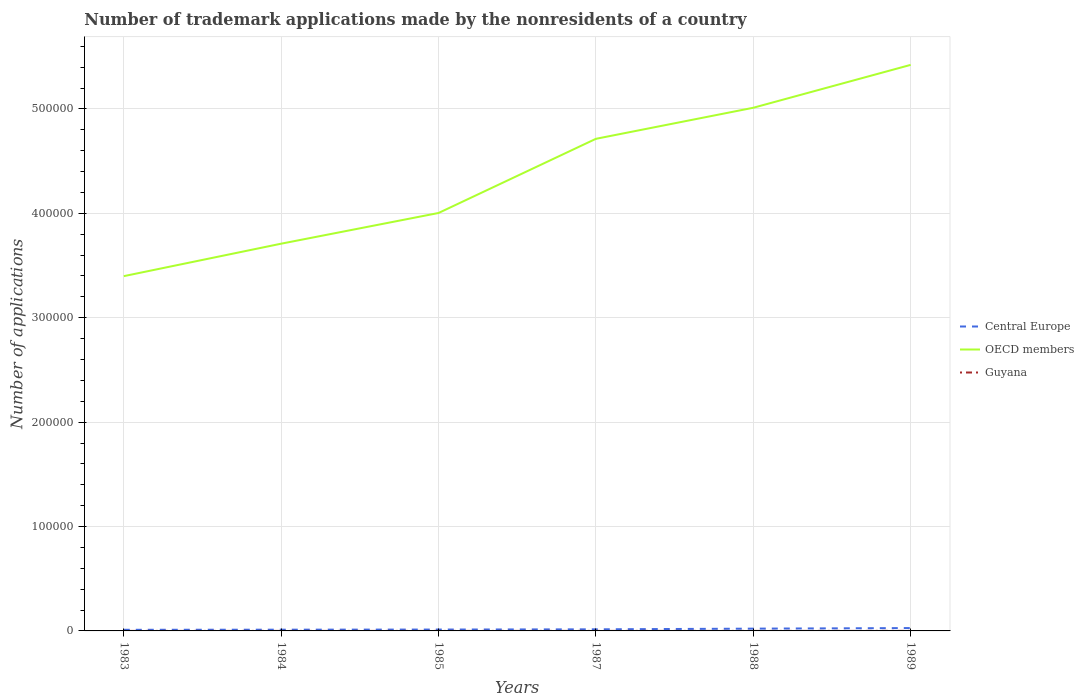Does the line corresponding to Guyana intersect with the line corresponding to Central Europe?
Your answer should be very brief. No. Across all years, what is the maximum number of trademark applications made by the nonresidents in Guyana?
Offer a terse response. 10. What is the total number of trademark applications made by the nonresidents in Central Europe in the graph?
Your response must be concise. -551. What is the difference between the highest and the second highest number of trademark applications made by the nonresidents in OECD members?
Your response must be concise. 2.02e+05. What is the difference between the highest and the lowest number of trademark applications made by the nonresidents in OECD members?
Your response must be concise. 3. Is the number of trademark applications made by the nonresidents in OECD members strictly greater than the number of trademark applications made by the nonresidents in Guyana over the years?
Your answer should be compact. No. How many lines are there?
Provide a succinct answer. 3. How many years are there in the graph?
Keep it short and to the point. 6. Are the values on the major ticks of Y-axis written in scientific E-notation?
Ensure brevity in your answer.  No. Does the graph contain any zero values?
Offer a very short reply. No. How many legend labels are there?
Your response must be concise. 3. What is the title of the graph?
Make the answer very short. Number of trademark applications made by the nonresidents of a country. What is the label or title of the X-axis?
Your response must be concise. Years. What is the label or title of the Y-axis?
Provide a short and direct response. Number of applications. What is the Number of applications in Central Europe in 1983?
Provide a short and direct response. 1070. What is the Number of applications of OECD members in 1983?
Make the answer very short. 3.40e+05. What is the Number of applications of Central Europe in 1984?
Offer a very short reply. 1181. What is the Number of applications in OECD members in 1984?
Ensure brevity in your answer.  3.71e+05. What is the Number of applications in Guyana in 1984?
Make the answer very short. 15. What is the Number of applications in Central Europe in 1985?
Give a very brief answer. 1312. What is the Number of applications in OECD members in 1985?
Make the answer very short. 4.00e+05. What is the Number of applications in Guyana in 1985?
Provide a short and direct response. 10. What is the Number of applications of Central Europe in 1987?
Your answer should be compact. 1528. What is the Number of applications of OECD members in 1987?
Give a very brief answer. 4.71e+05. What is the Number of applications in Guyana in 1987?
Your response must be concise. 29. What is the Number of applications in Central Europe in 1988?
Offer a very short reply. 2179. What is the Number of applications of OECD members in 1988?
Offer a terse response. 5.01e+05. What is the Number of applications of Central Europe in 1989?
Make the answer very short. 2730. What is the Number of applications of OECD members in 1989?
Provide a succinct answer. 5.42e+05. Across all years, what is the maximum Number of applications of Central Europe?
Offer a terse response. 2730. Across all years, what is the maximum Number of applications of OECD members?
Offer a terse response. 5.42e+05. Across all years, what is the maximum Number of applications in Guyana?
Keep it short and to the point. 47. Across all years, what is the minimum Number of applications of Central Europe?
Your response must be concise. 1070. Across all years, what is the minimum Number of applications of OECD members?
Your answer should be very brief. 3.40e+05. What is the total Number of applications of Central Europe in the graph?
Provide a succinct answer. 10000. What is the total Number of applications of OECD members in the graph?
Offer a terse response. 2.63e+06. What is the total Number of applications in Guyana in the graph?
Provide a succinct answer. 125. What is the difference between the Number of applications of Central Europe in 1983 and that in 1984?
Your answer should be compact. -111. What is the difference between the Number of applications in OECD members in 1983 and that in 1984?
Make the answer very short. -3.11e+04. What is the difference between the Number of applications in Central Europe in 1983 and that in 1985?
Keep it short and to the point. -242. What is the difference between the Number of applications of OECD members in 1983 and that in 1985?
Provide a succinct answer. -6.05e+04. What is the difference between the Number of applications of Central Europe in 1983 and that in 1987?
Your answer should be compact. -458. What is the difference between the Number of applications of OECD members in 1983 and that in 1987?
Your response must be concise. -1.32e+05. What is the difference between the Number of applications in Guyana in 1983 and that in 1987?
Give a very brief answer. -16. What is the difference between the Number of applications of Central Europe in 1983 and that in 1988?
Make the answer very short. -1109. What is the difference between the Number of applications of OECD members in 1983 and that in 1988?
Give a very brief answer. -1.61e+05. What is the difference between the Number of applications of Guyana in 1983 and that in 1988?
Give a very brief answer. 2. What is the difference between the Number of applications in Central Europe in 1983 and that in 1989?
Your answer should be very brief. -1660. What is the difference between the Number of applications of OECD members in 1983 and that in 1989?
Provide a succinct answer. -2.02e+05. What is the difference between the Number of applications of Guyana in 1983 and that in 1989?
Offer a very short reply. -34. What is the difference between the Number of applications of Central Europe in 1984 and that in 1985?
Offer a terse response. -131. What is the difference between the Number of applications in OECD members in 1984 and that in 1985?
Ensure brevity in your answer.  -2.94e+04. What is the difference between the Number of applications of Central Europe in 1984 and that in 1987?
Make the answer very short. -347. What is the difference between the Number of applications in OECD members in 1984 and that in 1987?
Ensure brevity in your answer.  -1.00e+05. What is the difference between the Number of applications in Central Europe in 1984 and that in 1988?
Give a very brief answer. -998. What is the difference between the Number of applications of OECD members in 1984 and that in 1988?
Provide a succinct answer. -1.30e+05. What is the difference between the Number of applications in Guyana in 1984 and that in 1988?
Make the answer very short. 4. What is the difference between the Number of applications of Central Europe in 1984 and that in 1989?
Your answer should be very brief. -1549. What is the difference between the Number of applications in OECD members in 1984 and that in 1989?
Provide a short and direct response. -1.71e+05. What is the difference between the Number of applications in Guyana in 1984 and that in 1989?
Provide a succinct answer. -32. What is the difference between the Number of applications in Central Europe in 1985 and that in 1987?
Offer a very short reply. -216. What is the difference between the Number of applications in OECD members in 1985 and that in 1987?
Your answer should be very brief. -7.10e+04. What is the difference between the Number of applications of Central Europe in 1985 and that in 1988?
Make the answer very short. -867. What is the difference between the Number of applications in OECD members in 1985 and that in 1988?
Give a very brief answer. -1.01e+05. What is the difference between the Number of applications in Central Europe in 1985 and that in 1989?
Your answer should be very brief. -1418. What is the difference between the Number of applications of OECD members in 1985 and that in 1989?
Your response must be concise. -1.42e+05. What is the difference between the Number of applications of Guyana in 1985 and that in 1989?
Provide a succinct answer. -37. What is the difference between the Number of applications in Central Europe in 1987 and that in 1988?
Ensure brevity in your answer.  -651. What is the difference between the Number of applications of OECD members in 1987 and that in 1988?
Your answer should be very brief. -2.98e+04. What is the difference between the Number of applications of Central Europe in 1987 and that in 1989?
Your answer should be compact. -1202. What is the difference between the Number of applications of OECD members in 1987 and that in 1989?
Provide a short and direct response. -7.08e+04. What is the difference between the Number of applications of Central Europe in 1988 and that in 1989?
Ensure brevity in your answer.  -551. What is the difference between the Number of applications of OECD members in 1988 and that in 1989?
Provide a succinct answer. -4.11e+04. What is the difference between the Number of applications of Guyana in 1988 and that in 1989?
Your answer should be very brief. -36. What is the difference between the Number of applications in Central Europe in 1983 and the Number of applications in OECD members in 1984?
Your answer should be compact. -3.70e+05. What is the difference between the Number of applications of Central Europe in 1983 and the Number of applications of Guyana in 1984?
Your answer should be compact. 1055. What is the difference between the Number of applications in OECD members in 1983 and the Number of applications in Guyana in 1984?
Ensure brevity in your answer.  3.40e+05. What is the difference between the Number of applications of Central Europe in 1983 and the Number of applications of OECD members in 1985?
Make the answer very short. -3.99e+05. What is the difference between the Number of applications of Central Europe in 1983 and the Number of applications of Guyana in 1985?
Provide a succinct answer. 1060. What is the difference between the Number of applications in OECD members in 1983 and the Number of applications in Guyana in 1985?
Your answer should be compact. 3.40e+05. What is the difference between the Number of applications of Central Europe in 1983 and the Number of applications of OECD members in 1987?
Your answer should be compact. -4.70e+05. What is the difference between the Number of applications in Central Europe in 1983 and the Number of applications in Guyana in 1987?
Make the answer very short. 1041. What is the difference between the Number of applications of OECD members in 1983 and the Number of applications of Guyana in 1987?
Your answer should be very brief. 3.40e+05. What is the difference between the Number of applications of Central Europe in 1983 and the Number of applications of OECD members in 1988?
Your answer should be compact. -5.00e+05. What is the difference between the Number of applications in Central Europe in 1983 and the Number of applications in Guyana in 1988?
Provide a short and direct response. 1059. What is the difference between the Number of applications in OECD members in 1983 and the Number of applications in Guyana in 1988?
Provide a short and direct response. 3.40e+05. What is the difference between the Number of applications of Central Europe in 1983 and the Number of applications of OECD members in 1989?
Your answer should be compact. -5.41e+05. What is the difference between the Number of applications of Central Europe in 1983 and the Number of applications of Guyana in 1989?
Provide a short and direct response. 1023. What is the difference between the Number of applications in OECD members in 1983 and the Number of applications in Guyana in 1989?
Make the answer very short. 3.40e+05. What is the difference between the Number of applications in Central Europe in 1984 and the Number of applications in OECD members in 1985?
Provide a short and direct response. -3.99e+05. What is the difference between the Number of applications in Central Europe in 1984 and the Number of applications in Guyana in 1985?
Your response must be concise. 1171. What is the difference between the Number of applications of OECD members in 1984 and the Number of applications of Guyana in 1985?
Provide a succinct answer. 3.71e+05. What is the difference between the Number of applications in Central Europe in 1984 and the Number of applications in OECD members in 1987?
Give a very brief answer. -4.70e+05. What is the difference between the Number of applications in Central Europe in 1984 and the Number of applications in Guyana in 1987?
Offer a terse response. 1152. What is the difference between the Number of applications in OECD members in 1984 and the Number of applications in Guyana in 1987?
Give a very brief answer. 3.71e+05. What is the difference between the Number of applications of Central Europe in 1984 and the Number of applications of OECD members in 1988?
Your response must be concise. -5.00e+05. What is the difference between the Number of applications of Central Europe in 1984 and the Number of applications of Guyana in 1988?
Ensure brevity in your answer.  1170. What is the difference between the Number of applications in OECD members in 1984 and the Number of applications in Guyana in 1988?
Your answer should be very brief. 3.71e+05. What is the difference between the Number of applications in Central Europe in 1984 and the Number of applications in OECD members in 1989?
Offer a very short reply. -5.41e+05. What is the difference between the Number of applications in Central Europe in 1984 and the Number of applications in Guyana in 1989?
Offer a terse response. 1134. What is the difference between the Number of applications in OECD members in 1984 and the Number of applications in Guyana in 1989?
Provide a short and direct response. 3.71e+05. What is the difference between the Number of applications of Central Europe in 1985 and the Number of applications of OECD members in 1987?
Ensure brevity in your answer.  -4.70e+05. What is the difference between the Number of applications in Central Europe in 1985 and the Number of applications in Guyana in 1987?
Make the answer very short. 1283. What is the difference between the Number of applications in OECD members in 1985 and the Number of applications in Guyana in 1987?
Offer a very short reply. 4.00e+05. What is the difference between the Number of applications in Central Europe in 1985 and the Number of applications in OECD members in 1988?
Ensure brevity in your answer.  -5.00e+05. What is the difference between the Number of applications of Central Europe in 1985 and the Number of applications of Guyana in 1988?
Provide a succinct answer. 1301. What is the difference between the Number of applications of OECD members in 1985 and the Number of applications of Guyana in 1988?
Offer a terse response. 4.00e+05. What is the difference between the Number of applications of Central Europe in 1985 and the Number of applications of OECD members in 1989?
Your answer should be very brief. -5.41e+05. What is the difference between the Number of applications of Central Europe in 1985 and the Number of applications of Guyana in 1989?
Offer a very short reply. 1265. What is the difference between the Number of applications of OECD members in 1985 and the Number of applications of Guyana in 1989?
Make the answer very short. 4.00e+05. What is the difference between the Number of applications in Central Europe in 1987 and the Number of applications in OECD members in 1988?
Your answer should be very brief. -5.00e+05. What is the difference between the Number of applications of Central Europe in 1987 and the Number of applications of Guyana in 1988?
Your answer should be compact. 1517. What is the difference between the Number of applications of OECD members in 1987 and the Number of applications of Guyana in 1988?
Ensure brevity in your answer.  4.71e+05. What is the difference between the Number of applications of Central Europe in 1987 and the Number of applications of OECD members in 1989?
Offer a terse response. -5.41e+05. What is the difference between the Number of applications in Central Europe in 1987 and the Number of applications in Guyana in 1989?
Give a very brief answer. 1481. What is the difference between the Number of applications of OECD members in 1987 and the Number of applications of Guyana in 1989?
Ensure brevity in your answer.  4.71e+05. What is the difference between the Number of applications in Central Europe in 1988 and the Number of applications in OECD members in 1989?
Ensure brevity in your answer.  -5.40e+05. What is the difference between the Number of applications of Central Europe in 1988 and the Number of applications of Guyana in 1989?
Your response must be concise. 2132. What is the difference between the Number of applications in OECD members in 1988 and the Number of applications in Guyana in 1989?
Ensure brevity in your answer.  5.01e+05. What is the average Number of applications in Central Europe per year?
Make the answer very short. 1666.67. What is the average Number of applications of OECD members per year?
Provide a succinct answer. 4.38e+05. What is the average Number of applications in Guyana per year?
Offer a terse response. 20.83. In the year 1983, what is the difference between the Number of applications of Central Europe and Number of applications of OECD members?
Your answer should be very brief. -3.39e+05. In the year 1983, what is the difference between the Number of applications in Central Europe and Number of applications in Guyana?
Ensure brevity in your answer.  1057. In the year 1983, what is the difference between the Number of applications in OECD members and Number of applications in Guyana?
Give a very brief answer. 3.40e+05. In the year 1984, what is the difference between the Number of applications of Central Europe and Number of applications of OECD members?
Your response must be concise. -3.70e+05. In the year 1984, what is the difference between the Number of applications in Central Europe and Number of applications in Guyana?
Make the answer very short. 1166. In the year 1984, what is the difference between the Number of applications of OECD members and Number of applications of Guyana?
Keep it short and to the point. 3.71e+05. In the year 1985, what is the difference between the Number of applications of Central Europe and Number of applications of OECD members?
Your answer should be very brief. -3.99e+05. In the year 1985, what is the difference between the Number of applications in Central Europe and Number of applications in Guyana?
Provide a short and direct response. 1302. In the year 1985, what is the difference between the Number of applications of OECD members and Number of applications of Guyana?
Give a very brief answer. 4.00e+05. In the year 1987, what is the difference between the Number of applications in Central Europe and Number of applications in OECD members?
Offer a very short reply. -4.70e+05. In the year 1987, what is the difference between the Number of applications of Central Europe and Number of applications of Guyana?
Provide a short and direct response. 1499. In the year 1987, what is the difference between the Number of applications of OECD members and Number of applications of Guyana?
Your answer should be very brief. 4.71e+05. In the year 1988, what is the difference between the Number of applications in Central Europe and Number of applications in OECD members?
Your response must be concise. -4.99e+05. In the year 1988, what is the difference between the Number of applications of Central Europe and Number of applications of Guyana?
Provide a short and direct response. 2168. In the year 1988, what is the difference between the Number of applications of OECD members and Number of applications of Guyana?
Give a very brief answer. 5.01e+05. In the year 1989, what is the difference between the Number of applications in Central Europe and Number of applications in OECD members?
Provide a succinct answer. -5.39e+05. In the year 1989, what is the difference between the Number of applications in Central Europe and Number of applications in Guyana?
Offer a very short reply. 2683. In the year 1989, what is the difference between the Number of applications in OECD members and Number of applications in Guyana?
Your response must be concise. 5.42e+05. What is the ratio of the Number of applications in Central Europe in 1983 to that in 1984?
Give a very brief answer. 0.91. What is the ratio of the Number of applications in OECD members in 1983 to that in 1984?
Keep it short and to the point. 0.92. What is the ratio of the Number of applications of Guyana in 1983 to that in 1984?
Make the answer very short. 0.87. What is the ratio of the Number of applications of Central Europe in 1983 to that in 1985?
Keep it short and to the point. 0.82. What is the ratio of the Number of applications of OECD members in 1983 to that in 1985?
Your response must be concise. 0.85. What is the ratio of the Number of applications in Guyana in 1983 to that in 1985?
Your response must be concise. 1.3. What is the ratio of the Number of applications in Central Europe in 1983 to that in 1987?
Ensure brevity in your answer.  0.7. What is the ratio of the Number of applications in OECD members in 1983 to that in 1987?
Keep it short and to the point. 0.72. What is the ratio of the Number of applications of Guyana in 1983 to that in 1987?
Your answer should be compact. 0.45. What is the ratio of the Number of applications in Central Europe in 1983 to that in 1988?
Ensure brevity in your answer.  0.49. What is the ratio of the Number of applications of OECD members in 1983 to that in 1988?
Ensure brevity in your answer.  0.68. What is the ratio of the Number of applications in Guyana in 1983 to that in 1988?
Give a very brief answer. 1.18. What is the ratio of the Number of applications in Central Europe in 1983 to that in 1989?
Offer a very short reply. 0.39. What is the ratio of the Number of applications in OECD members in 1983 to that in 1989?
Offer a very short reply. 0.63. What is the ratio of the Number of applications of Guyana in 1983 to that in 1989?
Provide a short and direct response. 0.28. What is the ratio of the Number of applications of Central Europe in 1984 to that in 1985?
Your answer should be very brief. 0.9. What is the ratio of the Number of applications in OECD members in 1984 to that in 1985?
Ensure brevity in your answer.  0.93. What is the ratio of the Number of applications of Guyana in 1984 to that in 1985?
Your answer should be compact. 1.5. What is the ratio of the Number of applications in Central Europe in 1984 to that in 1987?
Your response must be concise. 0.77. What is the ratio of the Number of applications of OECD members in 1984 to that in 1987?
Your answer should be compact. 0.79. What is the ratio of the Number of applications in Guyana in 1984 to that in 1987?
Provide a short and direct response. 0.52. What is the ratio of the Number of applications in Central Europe in 1984 to that in 1988?
Make the answer very short. 0.54. What is the ratio of the Number of applications in OECD members in 1984 to that in 1988?
Provide a succinct answer. 0.74. What is the ratio of the Number of applications in Guyana in 1984 to that in 1988?
Offer a terse response. 1.36. What is the ratio of the Number of applications of Central Europe in 1984 to that in 1989?
Your response must be concise. 0.43. What is the ratio of the Number of applications of OECD members in 1984 to that in 1989?
Your answer should be compact. 0.68. What is the ratio of the Number of applications in Guyana in 1984 to that in 1989?
Your answer should be compact. 0.32. What is the ratio of the Number of applications of Central Europe in 1985 to that in 1987?
Make the answer very short. 0.86. What is the ratio of the Number of applications of OECD members in 1985 to that in 1987?
Your answer should be compact. 0.85. What is the ratio of the Number of applications in Guyana in 1985 to that in 1987?
Keep it short and to the point. 0.34. What is the ratio of the Number of applications of Central Europe in 1985 to that in 1988?
Your answer should be very brief. 0.6. What is the ratio of the Number of applications in OECD members in 1985 to that in 1988?
Keep it short and to the point. 0.8. What is the ratio of the Number of applications of Guyana in 1985 to that in 1988?
Provide a succinct answer. 0.91. What is the ratio of the Number of applications of Central Europe in 1985 to that in 1989?
Keep it short and to the point. 0.48. What is the ratio of the Number of applications in OECD members in 1985 to that in 1989?
Keep it short and to the point. 0.74. What is the ratio of the Number of applications of Guyana in 1985 to that in 1989?
Give a very brief answer. 0.21. What is the ratio of the Number of applications of Central Europe in 1987 to that in 1988?
Make the answer very short. 0.7. What is the ratio of the Number of applications in OECD members in 1987 to that in 1988?
Your answer should be compact. 0.94. What is the ratio of the Number of applications in Guyana in 1987 to that in 1988?
Your response must be concise. 2.64. What is the ratio of the Number of applications of Central Europe in 1987 to that in 1989?
Offer a very short reply. 0.56. What is the ratio of the Number of applications of OECD members in 1987 to that in 1989?
Make the answer very short. 0.87. What is the ratio of the Number of applications of Guyana in 1987 to that in 1989?
Give a very brief answer. 0.62. What is the ratio of the Number of applications in Central Europe in 1988 to that in 1989?
Provide a succinct answer. 0.8. What is the ratio of the Number of applications in OECD members in 1988 to that in 1989?
Make the answer very short. 0.92. What is the ratio of the Number of applications in Guyana in 1988 to that in 1989?
Your answer should be compact. 0.23. What is the difference between the highest and the second highest Number of applications in Central Europe?
Offer a terse response. 551. What is the difference between the highest and the second highest Number of applications in OECD members?
Ensure brevity in your answer.  4.11e+04. What is the difference between the highest and the lowest Number of applications in Central Europe?
Give a very brief answer. 1660. What is the difference between the highest and the lowest Number of applications of OECD members?
Provide a succinct answer. 2.02e+05. 